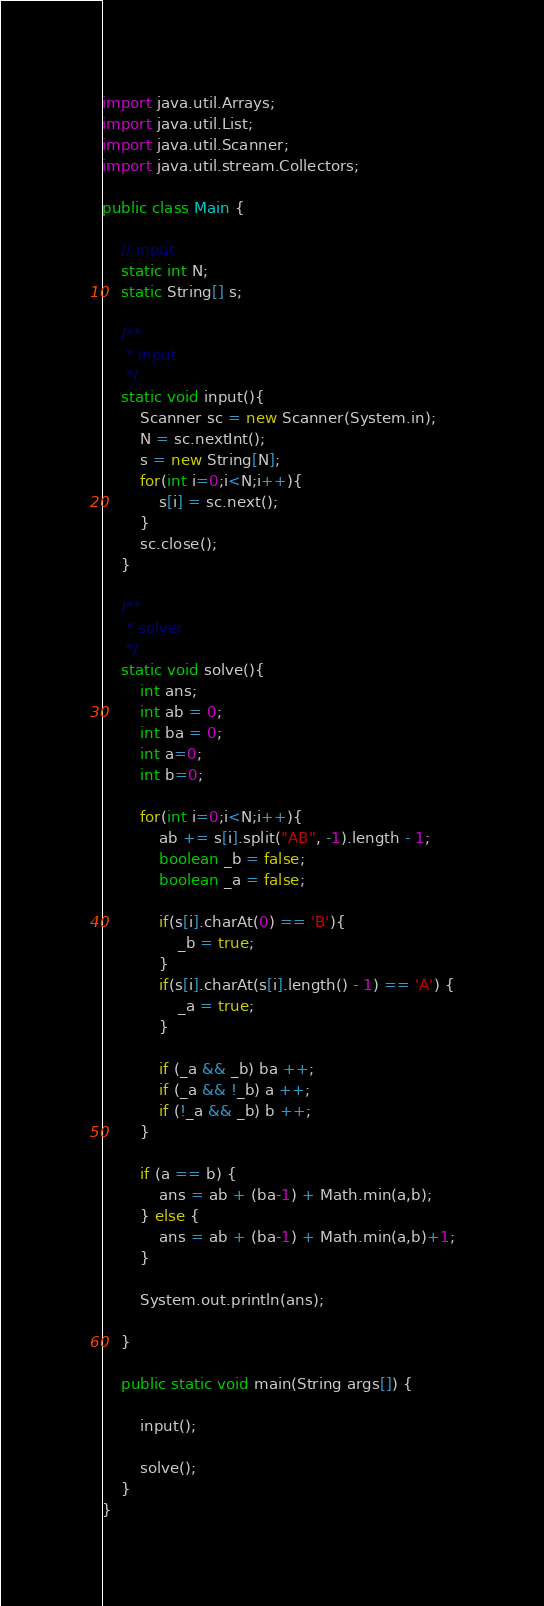<code> <loc_0><loc_0><loc_500><loc_500><_Java_>import java.util.Arrays;
import java.util.List;
import java.util.Scanner;
import java.util.stream.Collectors;

public class Main {

    // input
    static int N;
    static String[] s;

    /**
     * input
     */
    static void input(){
        Scanner sc = new Scanner(System.in);
        N = sc.nextInt();
        s = new String[N];
        for(int i=0;i<N;i++){
            s[i] = sc.next();
        }
        sc.close();
    }
 
    /**
     * solver
     */
    static void solve(){
        int ans;
        int ab = 0;
        int ba = 0;
        int a=0;
        int b=0;

        for(int i=0;i<N;i++){
            ab += s[i].split("AB", -1).length - 1;
            boolean _b = false;
            boolean _a = false;

            if(s[i].charAt(0) == 'B'){
                _b = true;
            }
            if(s[i].charAt(s[i].length() - 1) == 'A') {
                _a = true;
            }

            if (_a && _b) ba ++;
            if (_a && !_b) a ++;
            if (!_a && _b) b ++;
        }

        if (a == b) {
            ans = ab + (ba-1) + Math.min(a,b);
        } else {
            ans = ab + (ba-1) + Math.min(a,b)+1;
        }

        System.out.println(ans);

    }

    public static void main(String args[]) {

        input();

        solve();
    }
}
</code> 